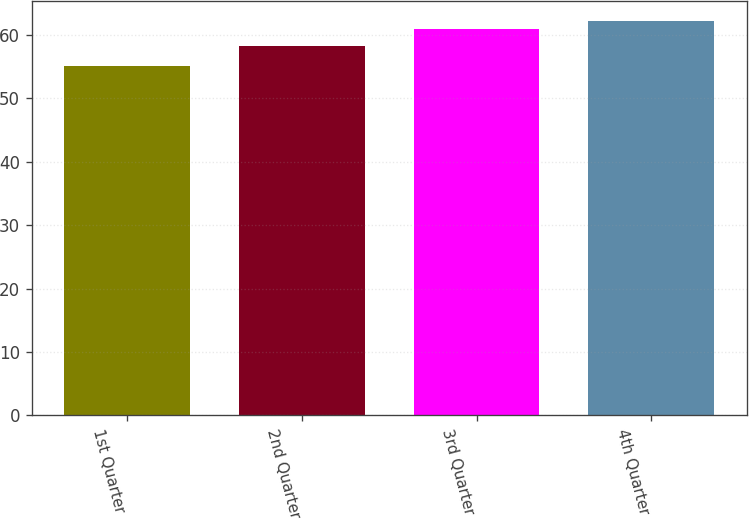Convert chart to OTSL. <chart><loc_0><loc_0><loc_500><loc_500><bar_chart><fcel>1st Quarter<fcel>2nd Quarter<fcel>3rd Quarter<fcel>4th Quarter<nl><fcel>55.05<fcel>58.2<fcel>60.96<fcel>62.26<nl></chart> 